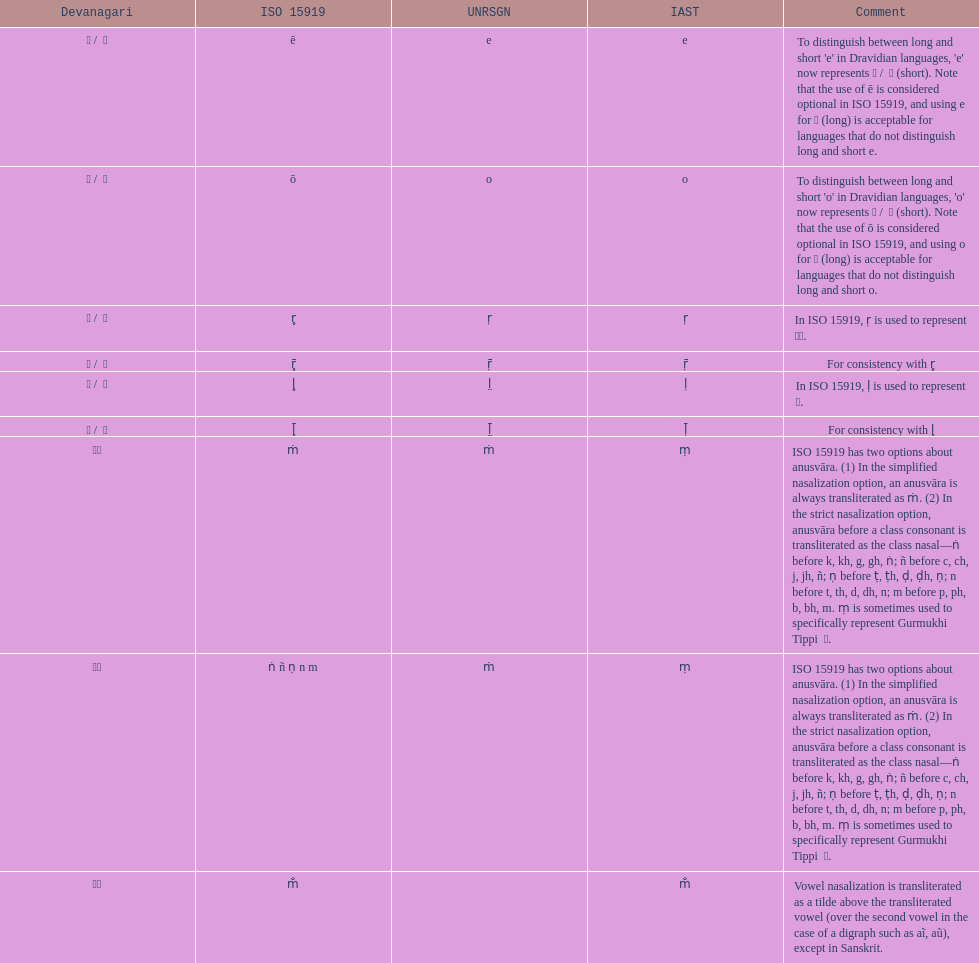Would you be able to parse every entry in this table? {'header': ['Devanagari', 'ISO 15919', 'UNRSGN', 'IAST', 'Comment'], 'rows': [['ए / \xa0े', 'ē', 'e', 'e', "To distinguish between long and short 'e' in Dravidian languages, 'e' now represents ऎ / \xa0ॆ (short). Note that the use of ē is considered optional in ISO 15919, and using e for ए (long) is acceptable for languages that do not distinguish long and short e."], ['ओ / \xa0ो', 'ō', 'o', 'o', "To distinguish between long and short 'o' in Dravidian languages, 'o' now represents ऒ / \xa0ॊ (short). Note that the use of ō is considered optional in ISO 15919, and using o for ओ (long) is acceptable for languages that do not distinguish long and short o."], ['ऋ / \xa0ृ', 'r̥', 'ṛ', 'ṛ', 'In ISO 15919, ṛ is used to represent ड़.'], ['ॠ / \xa0ॄ', 'r̥̄', 'ṝ', 'ṝ', 'For consistency with r̥'], ['ऌ / \xa0ॢ', 'l̥', 'l̤', 'ḷ', 'In ISO 15919, ḷ is used to represent ळ.'], ['ॡ / \xa0ॣ', 'l̥̄', 'l̤̄', 'ḹ', 'For consistency with l̥'], ['◌ं', 'ṁ', 'ṁ', 'ṃ', 'ISO 15919 has two options about anusvāra. (1) In the simplified nasalization option, an anusvāra is always transliterated as ṁ. (2) In the strict nasalization option, anusvāra before a class consonant is transliterated as the class nasal—ṅ before k, kh, g, gh, ṅ; ñ before c, ch, j, jh, ñ; ṇ before ṭ, ṭh, ḍ, ḍh, ṇ; n before t, th, d, dh, n; m before p, ph, b, bh, m. ṃ is sometimes used to specifically represent Gurmukhi Tippi \xa0ੰ.'], ['◌ं', 'ṅ ñ ṇ n m', 'ṁ', 'ṃ', 'ISO 15919 has two options about anusvāra. (1) In the simplified nasalization option, an anusvāra is always transliterated as ṁ. (2) In the strict nasalization option, anusvāra before a class consonant is transliterated as the class nasal—ṅ before k, kh, g, gh, ṅ; ñ before c, ch, j, jh, ñ; ṇ before ṭ, ṭh, ḍ, ḍh, ṇ; n before t, th, d, dh, n; m before p, ph, b, bh, m. ṃ is sometimes used to specifically represent Gurmukhi Tippi \xa0ੰ.'], ['◌ँ', 'm̐', '', 'm̐', 'Vowel nasalization is transliterated as a tilde above the transliterated vowel (over the second vowel in the case of a digraph such as aĩ, aũ), except in Sanskrit.']]} How many total options are there about anusvara? 2. 